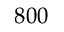Convert formula to latex. <formula><loc_0><loc_0><loc_500><loc_500>8 0 0</formula> 